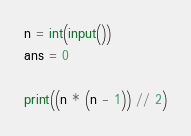Convert code to text. <code><loc_0><loc_0><loc_500><loc_500><_Python_>n = int(input())
ans = 0

print((n * (n - 1)) // 2)
</code> 